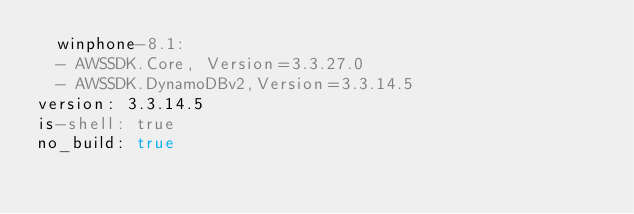Convert code to text. <code><loc_0><loc_0><loc_500><loc_500><_YAML_>  winphone-8.1:
  - AWSSDK.Core, Version=3.3.27.0
  - AWSSDK.DynamoDBv2,Version=3.3.14.5
version: 3.3.14.5
is-shell: true
no_build: true</code> 